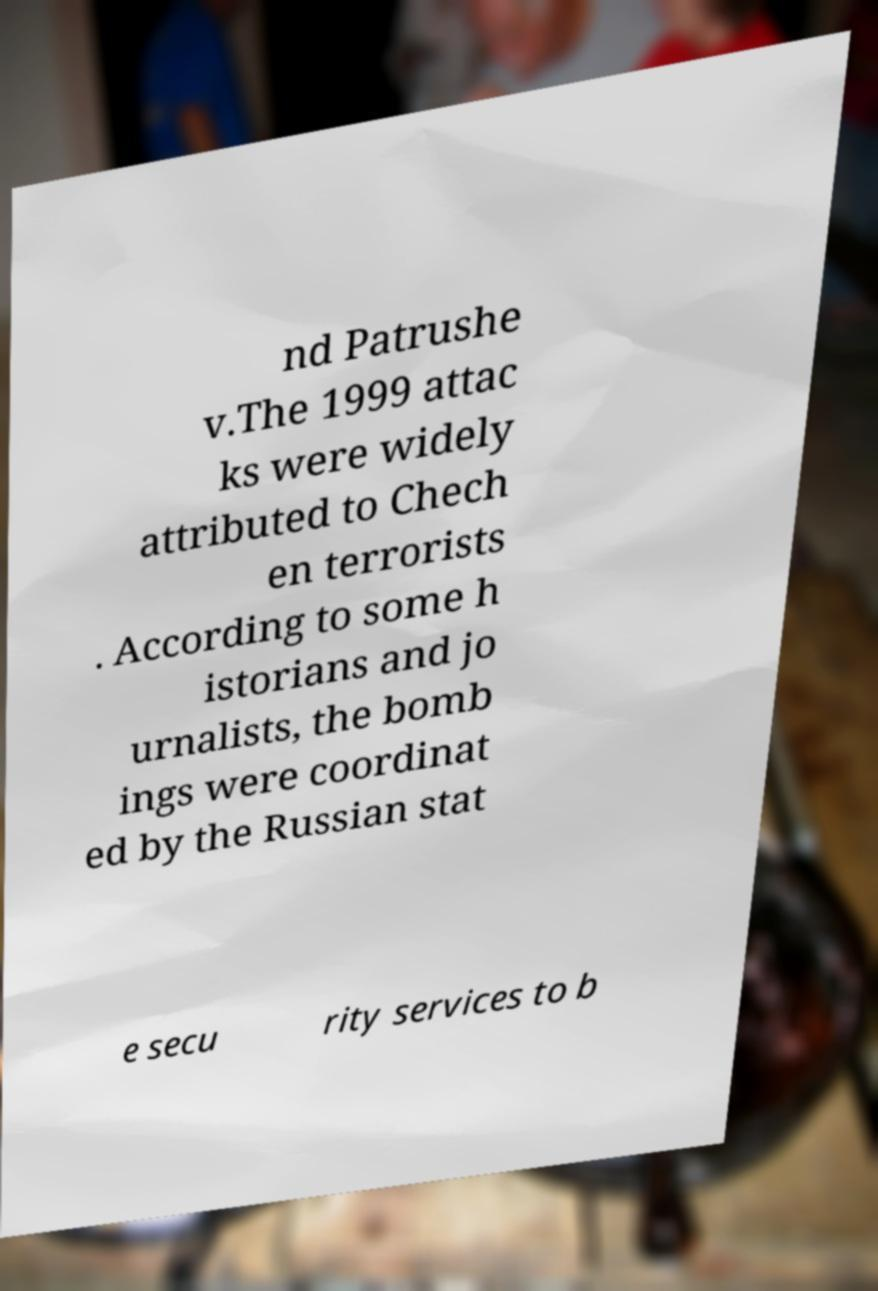Could you extract and type out the text from this image? nd Patrushe v.The 1999 attac ks were widely attributed to Chech en terrorists . According to some h istorians and jo urnalists, the bomb ings were coordinat ed by the Russian stat e secu rity services to b 